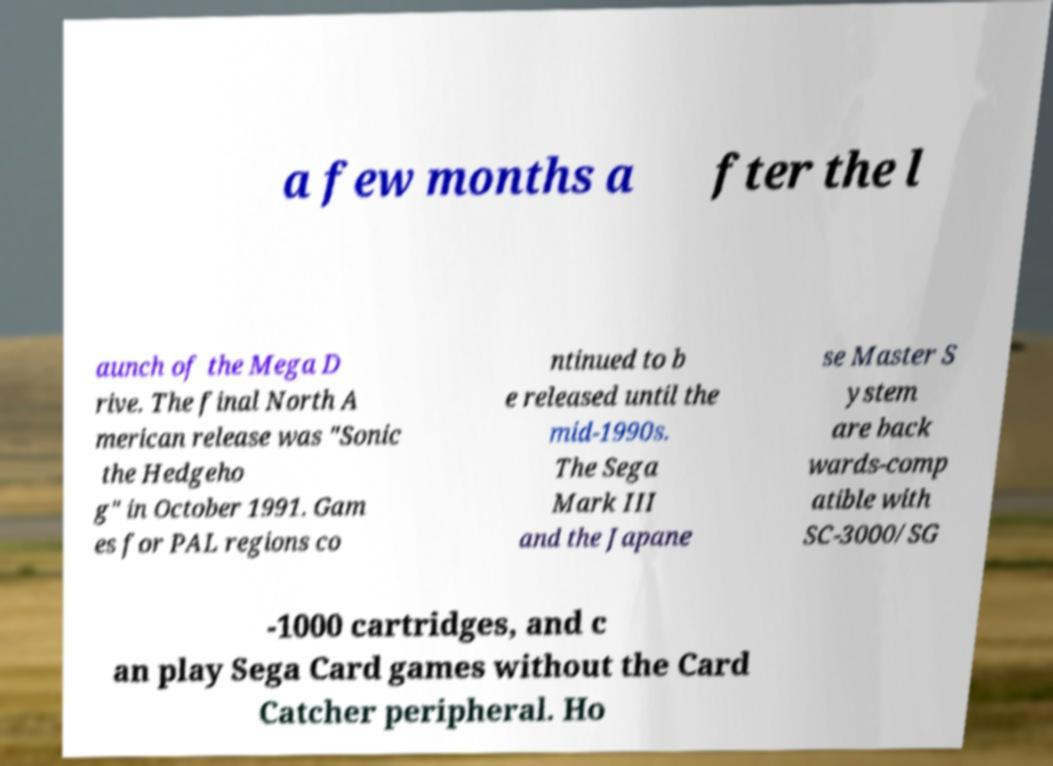Please identify and transcribe the text found in this image. a few months a fter the l aunch of the Mega D rive. The final North A merican release was "Sonic the Hedgeho g" in October 1991. Gam es for PAL regions co ntinued to b e released until the mid-1990s. The Sega Mark III and the Japane se Master S ystem are back wards-comp atible with SC-3000/SG -1000 cartridges, and c an play Sega Card games without the Card Catcher peripheral. Ho 